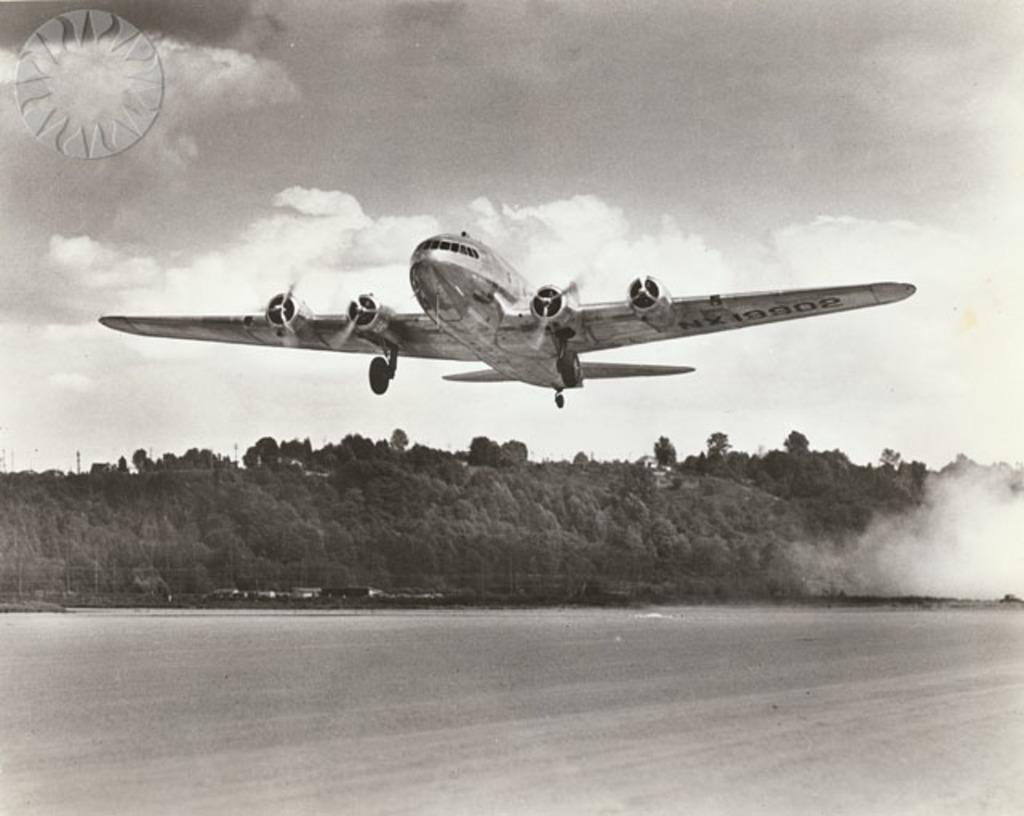What is the main subject of the image? The main subject of the image is an aircraft. What else can be seen in the image besides the aircraft? There are trees and the sky visible in the image. What type of toy can be seen on the chin of the person in the image? There is no person or toy present in the image; it features an aircraft, trees, and the sky. 